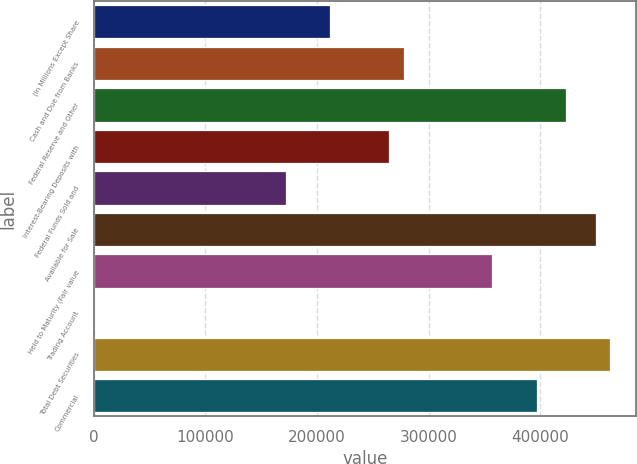Convert chart. <chart><loc_0><loc_0><loc_500><loc_500><bar_chart><fcel>(In Millions Except Share<fcel>Cash and Due from Banks<fcel>Federal Reserve and Other<fcel>Interest-Bearing Deposits with<fcel>Federal Funds Sold and<fcel>Available for Sale<fcel>Held to Maturity (Fair value<fcel>Trading Account<fcel>Total Debt Securities<fcel>Commercial<nl><fcel>211540<fcel>277646<fcel>423079<fcel>264425<fcel>171876<fcel>449522<fcel>356973<fcel>0.3<fcel>462743<fcel>396637<nl></chart> 